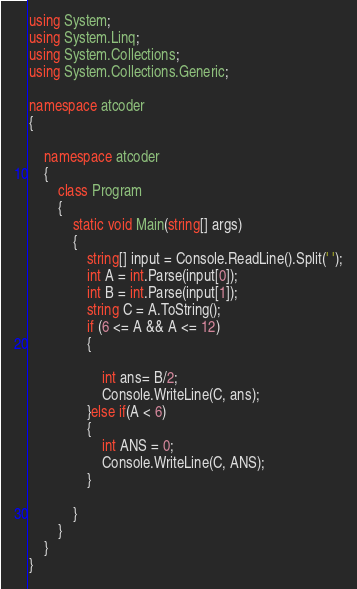Convert code to text. <code><loc_0><loc_0><loc_500><loc_500><_C#_>using System;
using System.Linq;
using System.Collections;
using System.Collections.Generic;

namespace atcoder
{

    namespace atcoder
    {
        class Program
        {
            static void Main(string[] args)
            {
                string[] input = Console.ReadLine().Split(' ');
                int A = int.Parse(input[0]);
                int B = int.Parse(input[1]);
                string C = A.ToString();
                if (6 <= A && A <= 12)
                {

                    int ans= B/2;
                    Console.WriteLine(C, ans);
                }else if(A < 6)
                {
                    int ANS = 0;
                    Console.WriteLine(C, ANS);
                }

            }
        }
    }
}</code> 